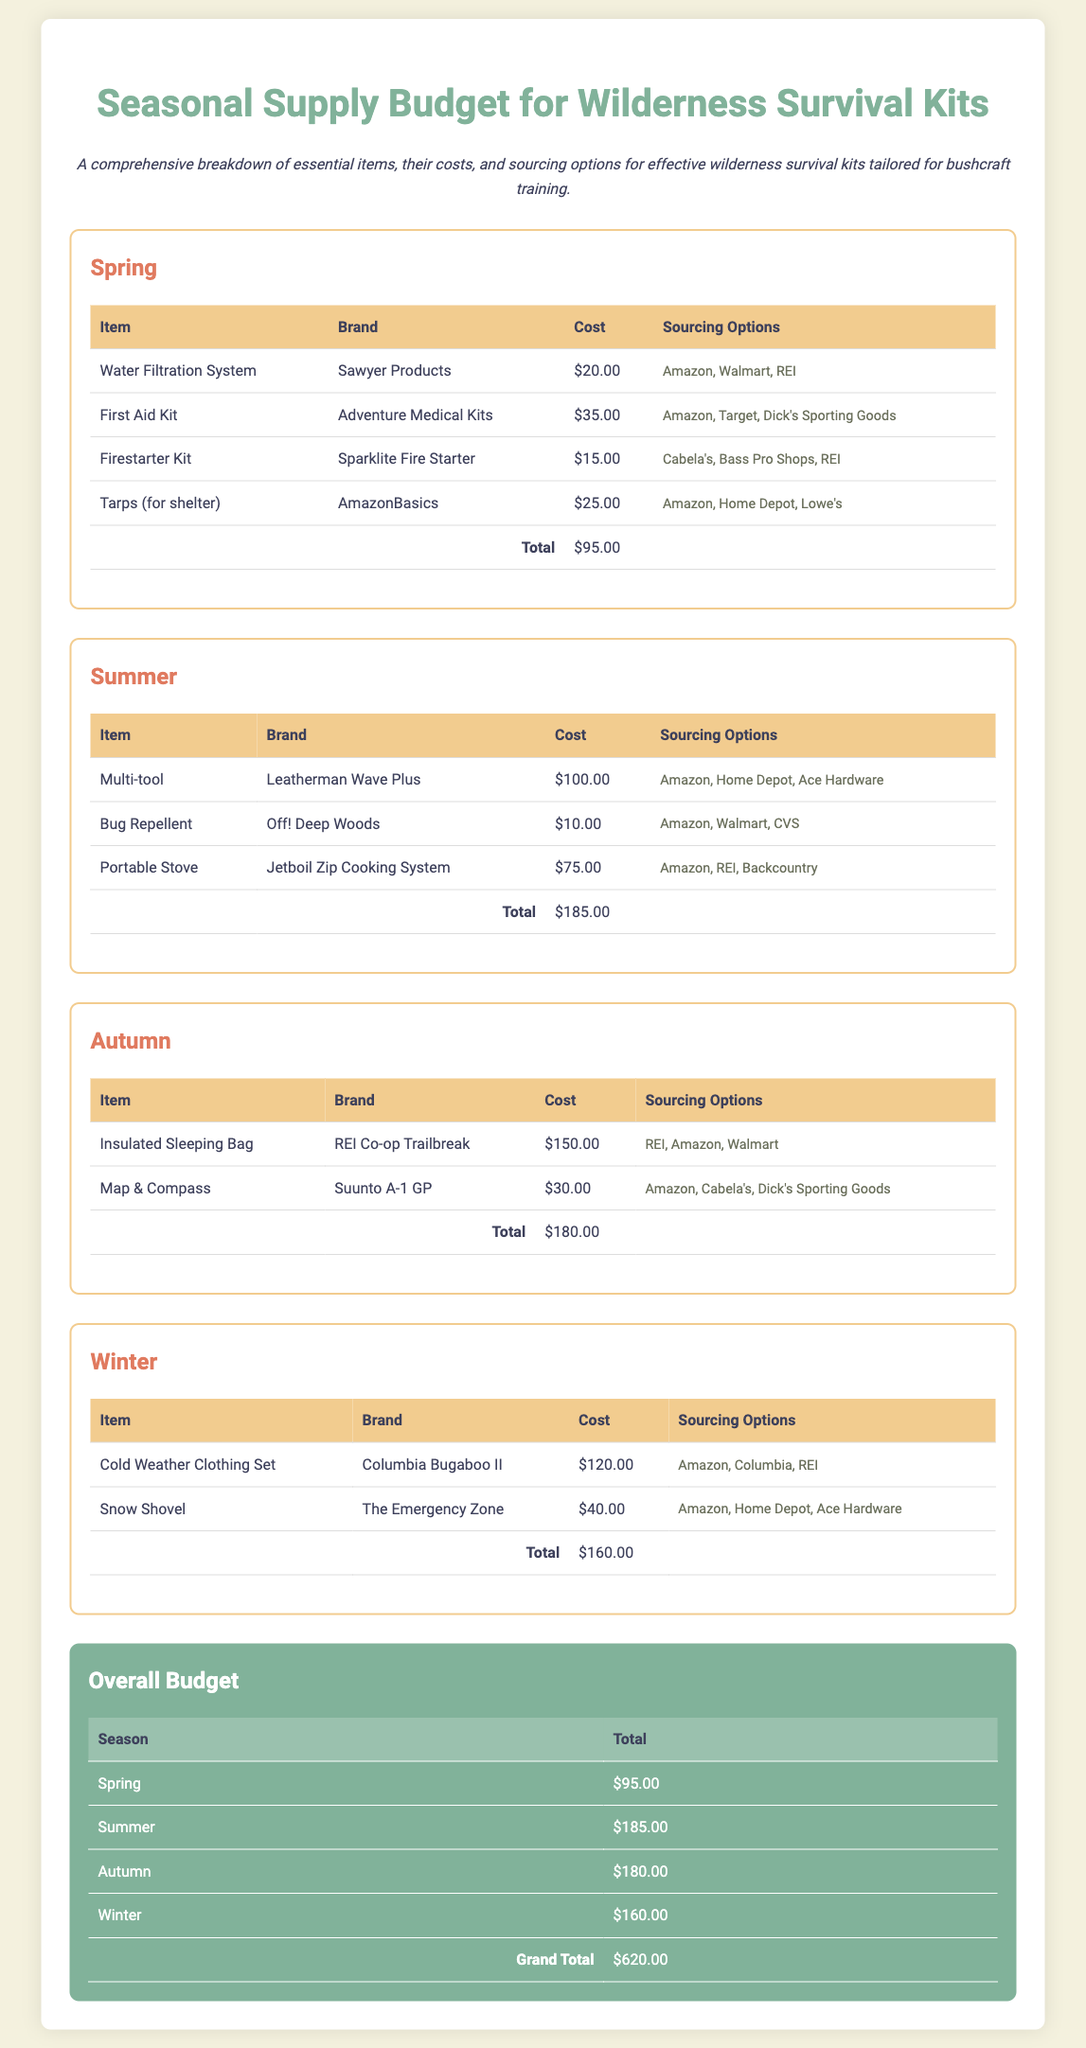What is the total cost for the Spring season? The total cost for the Spring season is provided at the bottom of the corresponding table, which is $95.00.
Answer: $95.00 Which item in the Summer section is the most expensive? The most expensive item in the Summer section is found by comparing the costs listed, which is the Multi-tool at $100.00.
Answer: Multi-tool How much does the Insulated Sleeping Bag cost? The cost of the Insulated Sleeping Bag is specified in the Autumn section of the document, which is $150.00.
Answer: $150.00 What brand is associated with the Water Filtration System? The brand associated with the Water Filtration System is listed in the Spring section, which is Sawyer Products.
Answer: Sawyer Products Which season has the highest total budget? By comparing the total budgets for each season, it is clear that the Summer season has the highest total of $185.00.
Answer: Summer What is the overall budget total across all seasons? The overall budget total is summarized at the end of the document, which adds up to $620.00.
Answer: $620.00 Where can the Firestarter Kit be sourced? The sourcing options for the Firestarter Kit are listed, which include Cabela's, Bass Pro Shops, and REI.
Answer: Cabela's, Bass Pro Shops, REI Which item in the Winter section is a clothing set? The Cold Weather Clothing Set is the item in the Winter section specifically identified as clothing.
Answer: Cold Weather Clothing Set What is the cost of the Portable Stove in the Summer section? The cost of the Portable Stove is explicitly stated in the Summer section, which is $75.00.
Answer: $75.00 